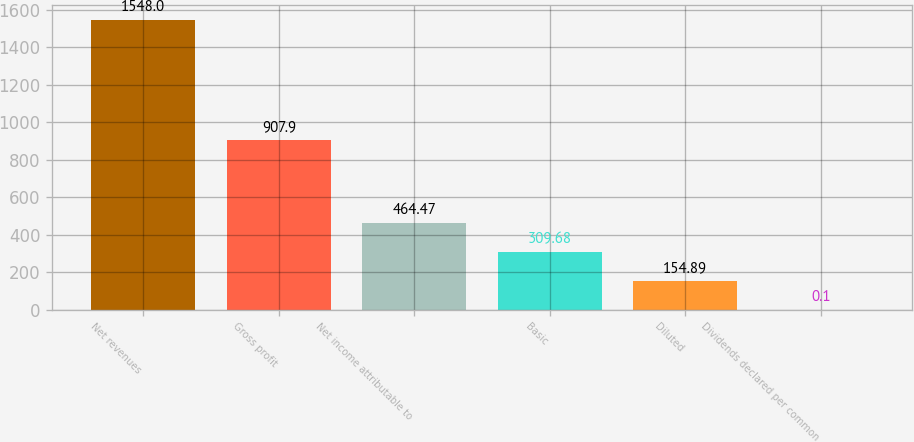Convert chart to OTSL. <chart><loc_0><loc_0><loc_500><loc_500><bar_chart><fcel>Net revenues<fcel>Gross profit<fcel>Net income attributable to<fcel>Basic<fcel>Diluted<fcel>Dividends declared per common<nl><fcel>1548<fcel>907.9<fcel>464.47<fcel>309.68<fcel>154.89<fcel>0.1<nl></chart> 